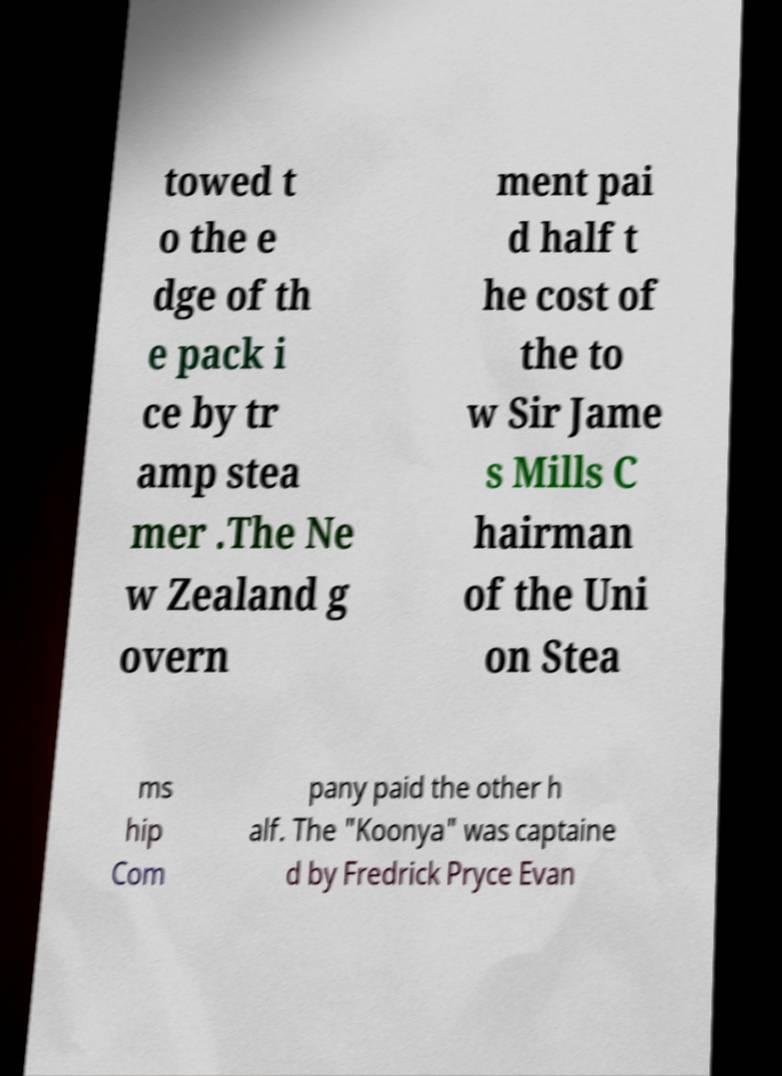Please read and relay the text visible in this image. What does it say? towed t o the e dge of th e pack i ce by tr amp stea mer .The Ne w Zealand g overn ment pai d half t he cost of the to w Sir Jame s Mills C hairman of the Uni on Stea ms hip Com pany paid the other h alf. The "Koonya" was captaine d by Fredrick Pryce Evan 